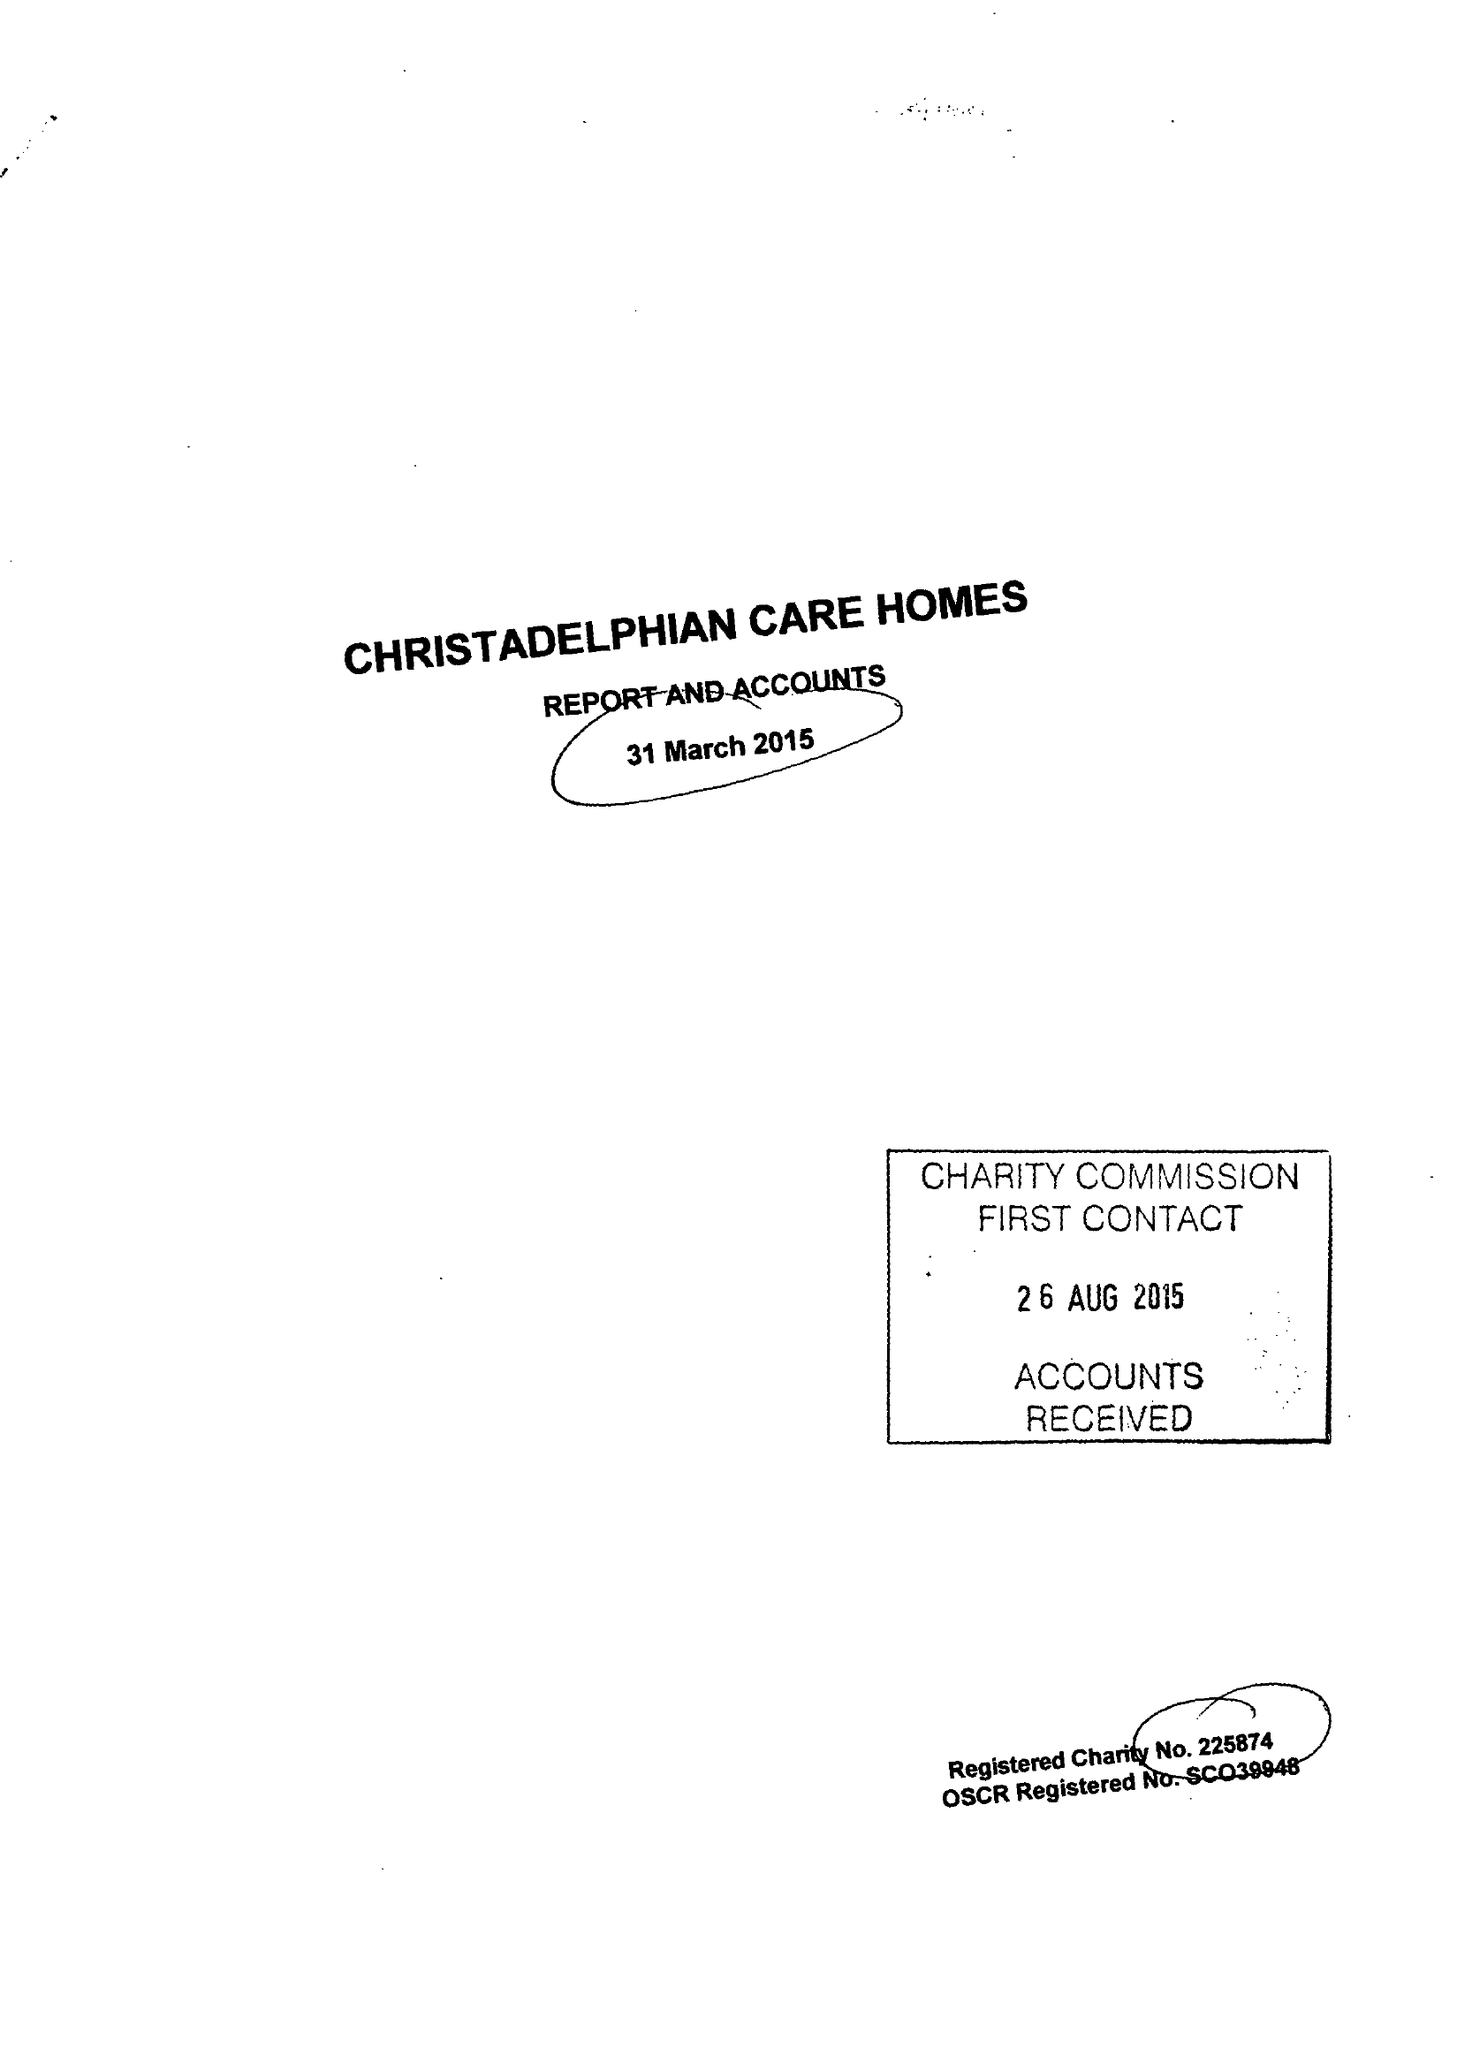What is the value for the report_date?
Answer the question using a single word or phrase. 2015-03-31 